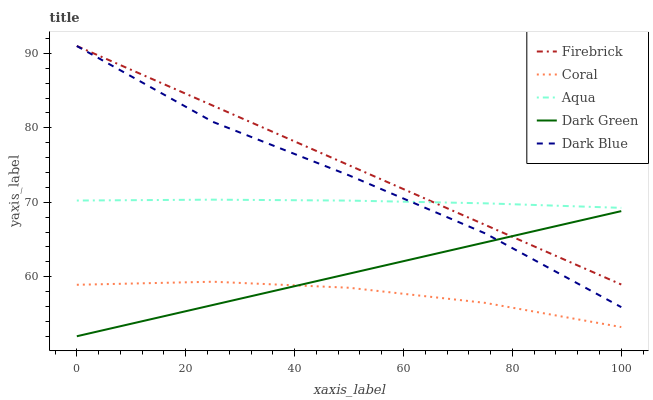Does Coral have the minimum area under the curve?
Answer yes or no. Yes. Does Firebrick have the maximum area under the curve?
Answer yes or no. Yes. Does Aqua have the minimum area under the curve?
Answer yes or no. No. Does Aqua have the maximum area under the curve?
Answer yes or no. No. Is Firebrick the smoothest?
Answer yes or no. Yes. Is Dark Blue the roughest?
Answer yes or no. Yes. Is Aqua the smoothest?
Answer yes or no. No. Is Aqua the roughest?
Answer yes or no. No. Does Dark Green have the lowest value?
Answer yes or no. Yes. Does Firebrick have the lowest value?
Answer yes or no. No. Does Firebrick have the highest value?
Answer yes or no. Yes. Does Aqua have the highest value?
Answer yes or no. No. Is Coral less than Firebrick?
Answer yes or no. Yes. Is Aqua greater than Coral?
Answer yes or no. Yes. Does Dark Green intersect Firebrick?
Answer yes or no. Yes. Is Dark Green less than Firebrick?
Answer yes or no. No. Is Dark Green greater than Firebrick?
Answer yes or no. No. Does Coral intersect Firebrick?
Answer yes or no. No. 